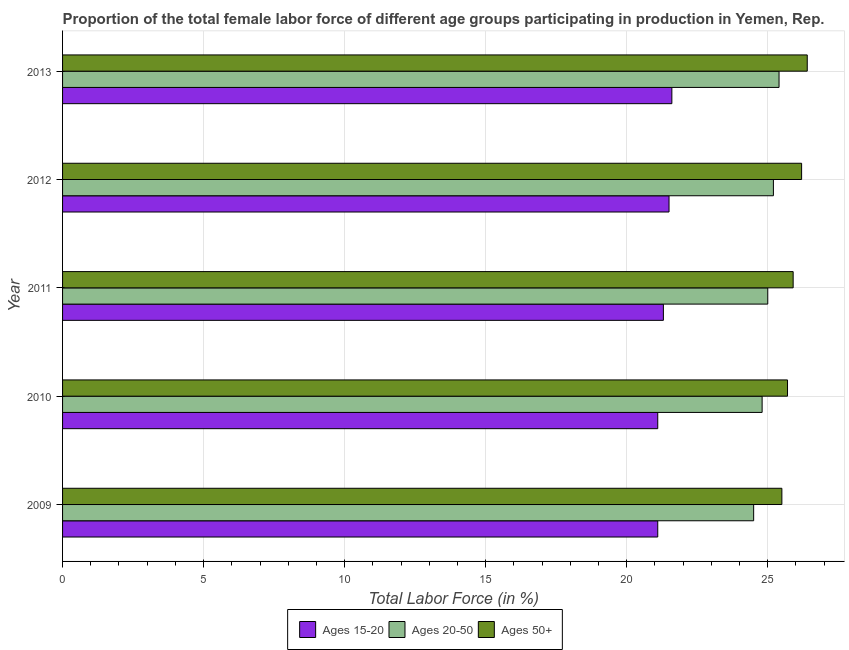How many bars are there on the 5th tick from the bottom?
Keep it short and to the point. 3. What is the label of the 2nd group of bars from the top?
Your answer should be compact. 2012. What is the percentage of female labor force within the age group 20-50 in 2010?
Provide a short and direct response. 24.8. Across all years, what is the maximum percentage of female labor force within the age group 15-20?
Give a very brief answer. 21.6. In which year was the percentage of female labor force above age 50 maximum?
Give a very brief answer. 2013. In which year was the percentage of female labor force within the age group 20-50 minimum?
Ensure brevity in your answer.  2009. What is the total percentage of female labor force within the age group 20-50 in the graph?
Ensure brevity in your answer.  124.9. What is the difference between the percentage of female labor force above age 50 in 2012 and that in 2013?
Give a very brief answer. -0.2. What is the difference between the percentage of female labor force within the age group 20-50 in 2012 and the percentage of female labor force within the age group 15-20 in 2011?
Your response must be concise. 3.9. What is the average percentage of female labor force above age 50 per year?
Offer a terse response. 25.94. What does the 3rd bar from the top in 2010 represents?
Offer a terse response. Ages 15-20. What does the 1st bar from the bottom in 2011 represents?
Your answer should be very brief. Ages 15-20. Is it the case that in every year, the sum of the percentage of female labor force within the age group 15-20 and percentage of female labor force within the age group 20-50 is greater than the percentage of female labor force above age 50?
Provide a short and direct response. Yes. Are all the bars in the graph horizontal?
Your answer should be very brief. Yes. What is the difference between two consecutive major ticks on the X-axis?
Your answer should be compact. 5. Are the values on the major ticks of X-axis written in scientific E-notation?
Your response must be concise. No. Does the graph contain any zero values?
Provide a short and direct response. No. Does the graph contain grids?
Give a very brief answer. Yes. Where does the legend appear in the graph?
Your answer should be very brief. Bottom center. How many legend labels are there?
Give a very brief answer. 3. How are the legend labels stacked?
Offer a terse response. Horizontal. What is the title of the graph?
Make the answer very short. Proportion of the total female labor force of different age groups participating in production in Yemen, Rep. Does "Taxes on goods and services" appear as one of the legend labels in the graph?
Make the answer very short. No. What is the label or title of the Y-axis?
Offer a terse response. Year. What is the Total Labor Force (in %) of Ages 15-20 in 2009?
Provide a short and direct response. 21.1. What is the Total Labor Force (in %) in Ages 50+ in 2009?
Offer a terse response. 25.5. What is the Total Labor Force (in %) in Ages 15-20 in 2010?
Keep it short and to the point. 21.1. What is the Total Labor Force (in %) in Ages 20-50 in 2010?
Your answer should be compact. 24.8. What is the Total Labor Force (in %) of Ages 50+ in 2010?
Offer a terse response. 25.7. What is the Total Labor Force (in %) of Ages 15-20 in 2011?
Your answer should be compact. 21.3. What is the Total Labor Force (in %) in Ages 20-50 in 2011?
Your answer should be compact. 25. What is the Total Labor Force (in %) of Ages 50+ in 2011?
Offer a very short reply. 25.9. What is the Total Labor Force (in %) in Ages 20-50 in 2012?
Offer a terse response. 25.2. What is the Total Labor Force (in %) of Ages 50+ in 2012?
Ensure brevity in your answer.  26.2. What is the Total Labor Force (in %) of Ages 15-20 in 2013?
Keep it short and to the point. 21.6. What is the Total Labor Force (in %) of Ages 20-50 in 2013?
Your answer should be very brief. 25.4. What is the Total Labor Force (in %) in Ages 50+ in 2013?
Give a very brief answer. 26.4. Across all years, what is the maximum Total Labor Force (in %) in Ages 15-20?
Your answer should be very brief. 21.6. Across all years, what is the maximum Total Labor Force (in %) in Ages 20-50?
Your answer should be very brief. 25.4. Across all years, what is the maximum Total Labor Force (in %) of Ages 50+?
Give a very brief answer. 26.4. Across all years, what is the minimum Total Labor Force (in %) in Ages 15-20?
Provide a succinct answer. 21.1. Across all years, what is the minimum Total Labor Force (in %) in Ages 20-50?
Your response must be concise. 24.5. Across all years, what is the minimum Total Labor Force (in %) of Ages 50+?
Your answer should be very brief. 25.5. What is the total Total Labor Force (in %) of Ages 15-20 in the graph?
Make the answer very short. 106.6. What is the total Total Labor Force (in %) of Ages 20-50 in the graph?
Keep it short and to the point. 124.9. What is the total Total Labor Force (in %) of Ages 50+ in the graph?
Make the answer very short. 129.7. What is the difference between the Total Labor Force (in %) of Ages 15-20 in 2009 and that in 2010?
Your response must be concise. 0. What is the difference between the Total Labor Force (in %) in Ages 15-20 in 2009 and that in 2011?
Keep it short and to the point. -0.2. What is the difference between the Total Labor Force (in %) of Ages 50+ in 2009 and that in 2011?
Offer a terse response. -0.4. What is the difference between the Total Labor Force (in %) in Ages 20-50 in 2009 and that in 2013?
Offer a terse response. -0.9. What is the difference between the Total Labor Force (in %) in Ages 15-20 in 2010 and that in 2011?
Offer a terse response. -0.2. What is the difference between the Total Labor Force (in %) in Ages 20-50 in 2010 and that in 2011?
Your answer should be very brief. -0.2. What is the difference between the Total Labor Force (in %) in Ages 50+ in 2010 and that in 2011?
Ensure brevity in your answer.  -0.2. What is the difference between the Total Labor Force (in %) in Ages 50+ in 2010 and that in 2012?
Offer a terse response. -0.5. What is the difference between the Total Labor Force (in %) of Ages 50+ in 2010 and that in 2013?
Your response must be concise. -0.7. What is the difference between the Total Labor Force (in %) in Ages 15-20 in 2011 and that in 2012?
Offer a terse response. -0.2. What is the difference between the Total Labor Force (in %) of Ages 15-20 in 2011 and that in 2013?
Offer a terse response. -0.3. What is the difference between the Total Labor Force (in %) of Ages 50+ in 2011 and that in 2013?
Give a very brief answer. -0.5. What is the difference between the Total Labor Force (in %) in Ages 50+ in 2012 and that in 2013?
Make the answer very short. -0.2. What is the difference between the Total Labor Force (in %) in Ages 15-20 in 2009 and the Total Labor Force (in %) in Ages 50+ in 2010?
Give a very brief answer. -4.6. What is the difference between the Total Labor Force (in %) of Ages 20-50 in 2009 and the Total Labor Force (in %) of Ages 50+ in 2010?
Offer a terse response. -1.2. What is the difference between the Total Labor Force (in %) in Ages 20-50 in 2009 and the Total Labor Force (in %) in Ages 50+ in 2011?
Your answer should be very brief. -1.4. What is the difference between the Total Labor Force (in %) of Ages 15-20 in 2009 and the Total Labor Force (in %) of Ages 20-50 in 2012?
Your answer should be very brief. -4.1. What is the difference between the Total Labor Force (in %) of Ages 20-50 in 2009 and the Total Labor Force (in %) of Ages 50+ in 2012?
Ensure brevity in your answer.  -1.7. What is the difference between the Total Labor Force (in %) of Ages 15-20 in 2009 and the Total Labor Force (in %) of Ages 50+ in 2013?
Provide a succinct answer. -5.3. What is the difference between the Total Labor Force (in %) in Ages 15-20 in 2010 and the Total Labor Force (in %) in Ages 50+ in 2011?
Keep it short and to the point. -4.8. What is the difference between the Total Labor Force (in %) of Ages 20-50 in 2010 and the Total Labor Force (in %) of Ages 50+ in 2011?
Offer a very short reply. -1.1. What is the difference between the Total Labor Force (in %) of Ages 20-50 in 2010 and the Total Labor Force (in %) of Ages 50+ in 2012?
Your response must be concise. -1.4. What is the difference between the Total Labor Force (in %) in Ages 15-20 in 2010 and the Total Labor Force (in %) in Ages 20-50 in 2013?
Provide a short and direct response. -4.3. What is the difference between the Total Labor Force (in %) in Ages 15-20 in 2010 and the Total Labor Force (in %) in Ages 50+ in 2013?
Give a very brief answer. -5.3. What is the difference between the Total Labor Force (in %) of Ages 20-50 in 2010 and the Total Labor Force (in %) of Ages 50+ in 2013?
Your answer should be compact. -1.6. What is the difference between the Total Labor Force (in %) of Ages 15-20 in 2011 and the Total Labor Force (in %) of Ages 20-50 in 2012?
Make the answer very short. -3.9. What is the difference between the Total Labor Force (in %) of Ages 20-50 in 2011 and the Total Labor Force (in %) of Ages 50+ in 2012?
Offer a very short reply. -1.2. What is the difference between the Total Labor Force (in %) in Ages 15-20 in 2011 and the Total Labor Force (in %) in Ages 20-50 in 2013?
Provide a succinct answer. -4.1. What is the difference between the Total Labor Force (in %) in Ages 20-50 in 2011 and the Total Labor Force (in %) in Ages 50+ in 2013?
Your answer should be compact. -1.4. What is the difference between the Total Labor Force (in %) of Ages 15-20 in 2012 and the Total Labor Force (in %) of Ages 20-50 in 2013?
Provide a short and direct response. -3.9. What is the average Total Labor Force (in %) of Ages 15-20 per year?
Keep it short and to the point. 21.32. What is the average Total Labor Force (in %) of Ages 20-50 per year?
Offer a terse response. 24.98. What is the average Total Labor Force (in %) in Ages 50+ per year?
Your answer should be very brief. 25.94. In the year 2009, what is the difference between the Total Labor Force (in %) in Ages 15-20 and Total Labor Force (in %) in Ages 20-50?
Your response must be concise. -3.4. In the year 2009, what is the difference between the Total Labor Force (in %) of Ages 20-50 and Total Labor Force (in %) of Ages 50+?
Your response must be concise. -1. In the year 2010, what is the difference between the Total Labor Force (in %) in Ages 15-20 and Total Labor Force (in %) in Ages 20-50?
Provide a succinct answer. -3.7. In the year 2010, what is the difference between the Total Labor Force (in %) in Ages 15-20 and Total Labor Force (in %) in Ages 50+?
Your response must be concise. -4.6. In the year 2011, what is the difference between the Total Labor Force (in %) in Ages 15-20 and Total Labor Force (in %) in Ages 50+?
Your response must be concise. -4.6. In the year 2011, what is the difference between the Total Labor Force (in %) of Ages 20-50 and Total Labor Force (in %) of Ages 50+?
Your answer should be very brief. -0.9. In the year 2012, what is the difference between the Total Labor Force (in %) of Ages 15-20 and Total Labor Force (in %) of Ages 20-50?
Offer a very short reply. -3.7. In the year 2012, what is the difference between the Total Labor Force (in %) of Ages 15-20 and Total Labor Force (in %) of Ages 50+?
Ensure brevity in your answer.  -4.7. In the year 2012, what is the difference between the Total Labor Force (in %) in Ages 20-50 and Total Labor Force (in %) in Ages 50+?
Provide a succinct answer. -1. In the year 2013, what is the difference between the Total Labor Force (in %) in Ages 15-20 and Total Labor Force (in %) in Ages 20-50?
Your response must be concise. -3.8. In the year 2013, what is the difference between the Total Labor Force (in %) in Ages 15-20 and Total Labor Force (in %) in Ages 50+?
Your answer should be very brief. -4.8. What is the ratio of the Total Labor Force (in %) of Ages 15-20 in 2009 to that in 2010?
Give a very brief answer. 1. What is the ratio of the Total Labor Force (in %) in Ages 20-50 in 2009 to that in 2010?
Provide a short and direct response. 0.99. What is the ratio of the Total Labor Force (in %) in Ages 15-20 in 2009 to that in 2011?
Keep it short and to the point. 0.99. What is the ratio of the Total Labor Force (in %) in Ages 50+ in 2009 to that in 2011?
Keep it short and to the point. 0.98. What is the ratio of the Total Labor Force (in %) in Ages 15-20 in 2009 to that in 2012?
Give a very brief answer. 0.98. What is the ratio of the Total Labor Force (in %) of Ages 20-50 in 2009 to that in 2012?
Your answer should be very brief. 0.97. What is the ratio of the Total Labor Force (in %) in Ages 50+ in 2009 to that in 2012?
Keep it short and to the point. 0.97. What is the ratio of the Total Labor Force (in %) of Ages 15-20 in 2009 to that in 2013?
Offer a terse response. 0.98. What is the ratio of the Total Labor Force (in %) in Ages 20-50 in 2009 to that in 2013?
Make the answer very short. 0.96. What is the ratio of the Total Labor Force (in %) of Ages 50+ in 2009 to that in 2013?
Your answer should be very brief. 0.97. What is the ratio of the Total Labor Force (in %) in Ages 15-20 in 2010 to that in 2011?
Keep it short and to the point. 0.99. What is the ratio of the Total Labor Force (in %) in Ages 15-20 in 2010 to that in 2012?
Give a very brief answer. 0.98. What is the ratio of the Total Labor Force (in %) in Ages 20-50 in 2010 to that in 2012?
Make the answer very short. 0.98. What is the ratio of the Total Labor Force (in %) of Ages 50+ in 2010 to that in 2012?
Your answer should be very brief. 0.98. What is the ratio of the Total Labor Force (in %) in Ages 15-20 in 2010 to that in 2013?
Offer a terse response. 0.98. What is the ratio of the Total Labor Force (in %) in Ages 20-50 in 2010 to that in 2013?
Offer a terse response. 0.98. What is the ratio of the Total Labor Force (in %) of Ages 50+ in 2010 to that in 2013?
Give a very brief answer. 0.97. What is the ratio of the Total Labor Force (in %) in Ages 20-50 in 2011 to that in 2012?
Your answer should be very brief. 0.99. What is the ratio of the Total Labor Force (in %) in Ages 15-20 in 2011 to that in 2013?
Keep it short and to the point. 0.99. What is the ratio of the Total Labor Force (in %) of Ages 20-50 in 2011 to that in 2013?
Provide a succinct answer. 0.98. What is the ratio of the Total Labor Force (in %) of Ages 50+ in 2011 to that in 2013?
Ensure brevity in your answer.  0.98. What is the ratio of the Total Labor Force (in %) of Ages 15-20 in 2012 to that in 2013?
Offer a very short reply. 1. What is the ratio of the Total Labor Force (in %) in Ages 20-50 in 2012 to that in 2013?
Provide a short and direct response. 0.99. What is the ratio of the Total Labor Force (in %) in Ages 50+ in 2012 to that in 2013?
Offer a very short reply. 0.99. What is the difference between the highest and the second highest Total Labor Force (in %) of Ages 20-50?
Your response must be concise. 0.2. What is the difference between the highest and the second highest Total Labor Force (in %) of Ages 50+?
Provide a succinct answer. 0.2. What is the difference between the highest and the lowest Total Labor Force (in %) in Ages 15-20?
Provide a short and direct response. 0.5. 